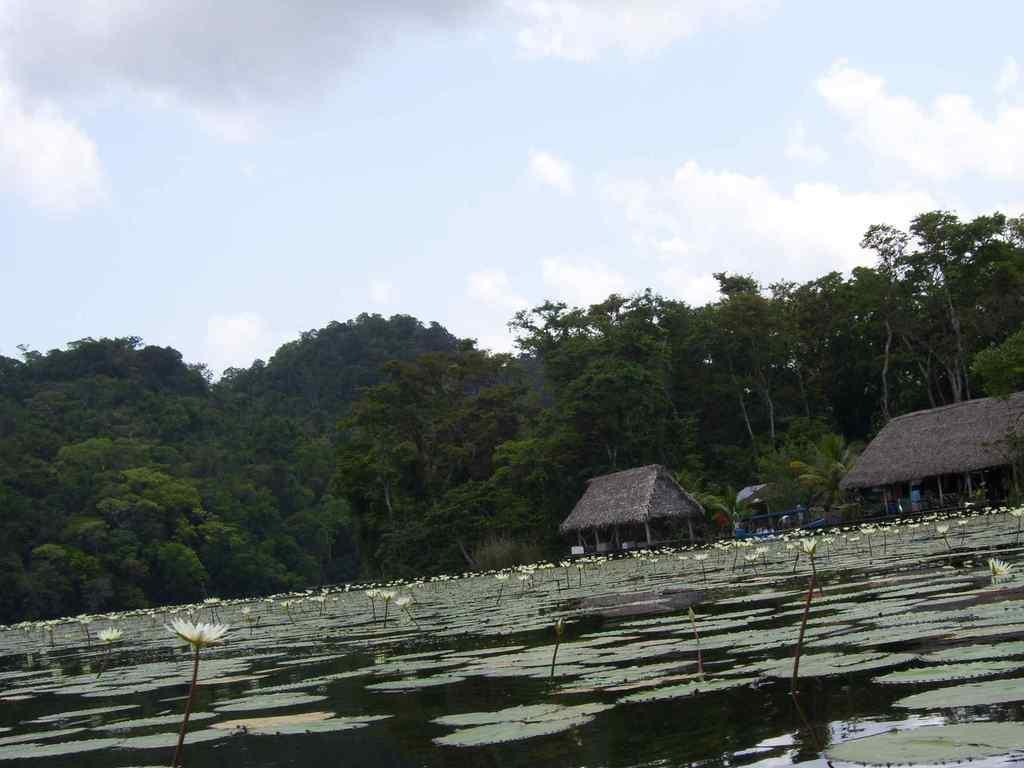In one or two sentences, can you explain what this image depicts? At the bottom of this image there is a sea in which I can see some lily flowers and leaves on the water. In the background there are two hits and some trees. On the top of the image I can see the sky and clouds. 